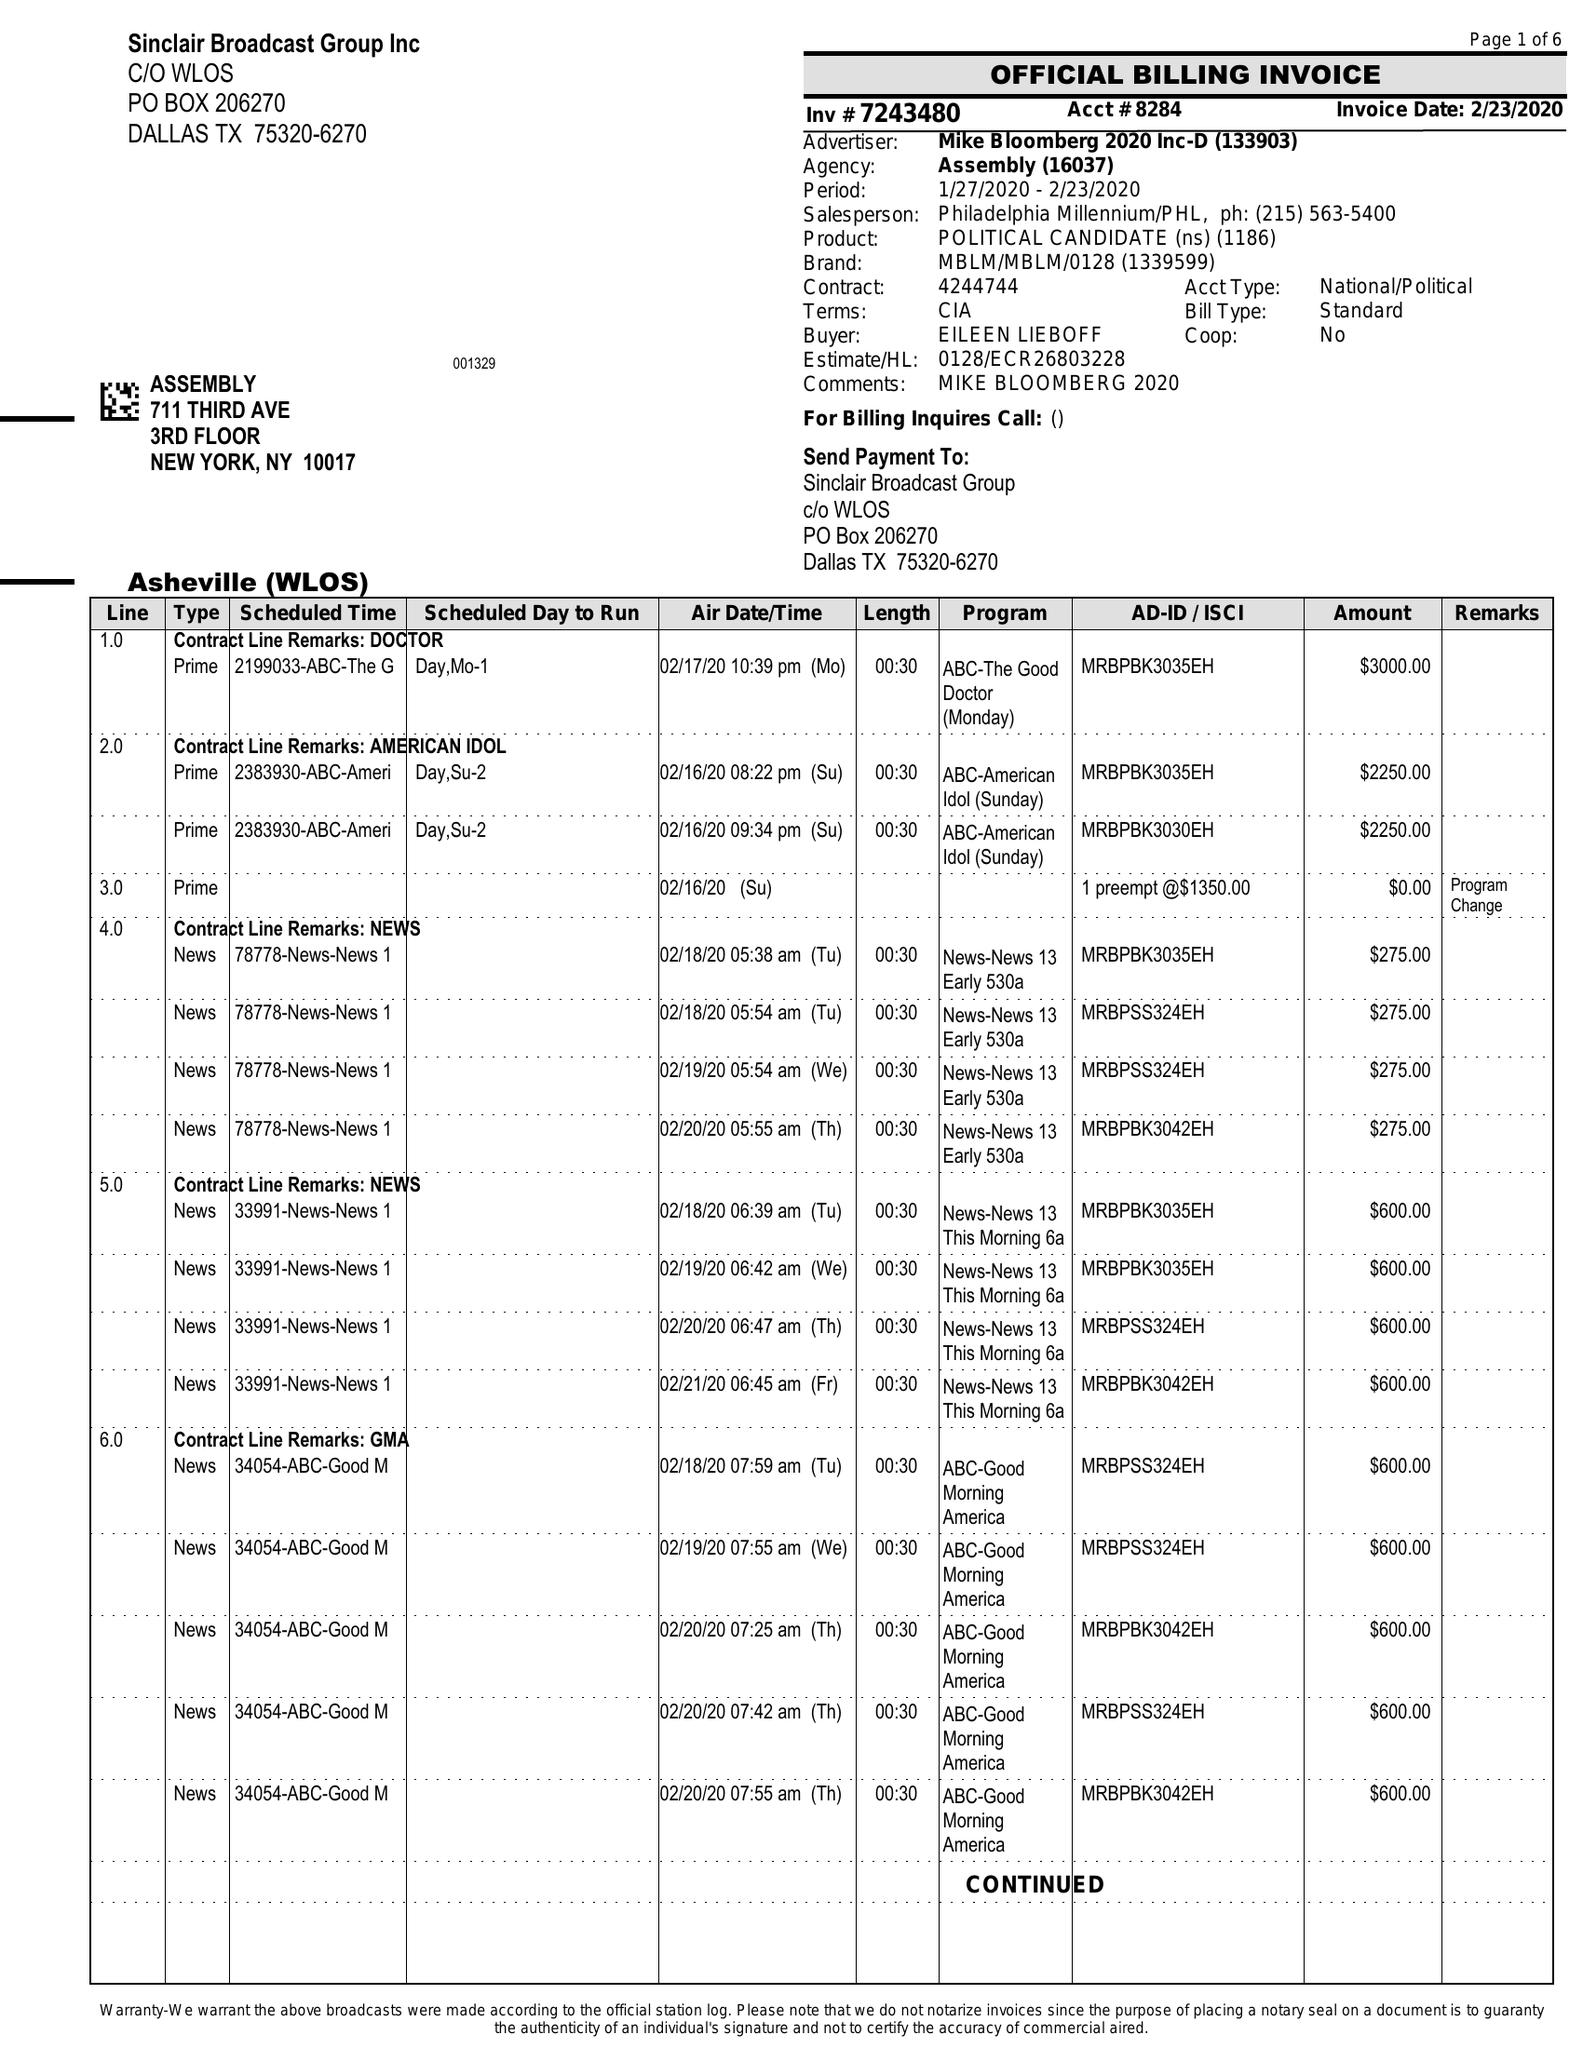What is the value for the flight_from?
Answer the question using a single word or phrase. 01/27/20 